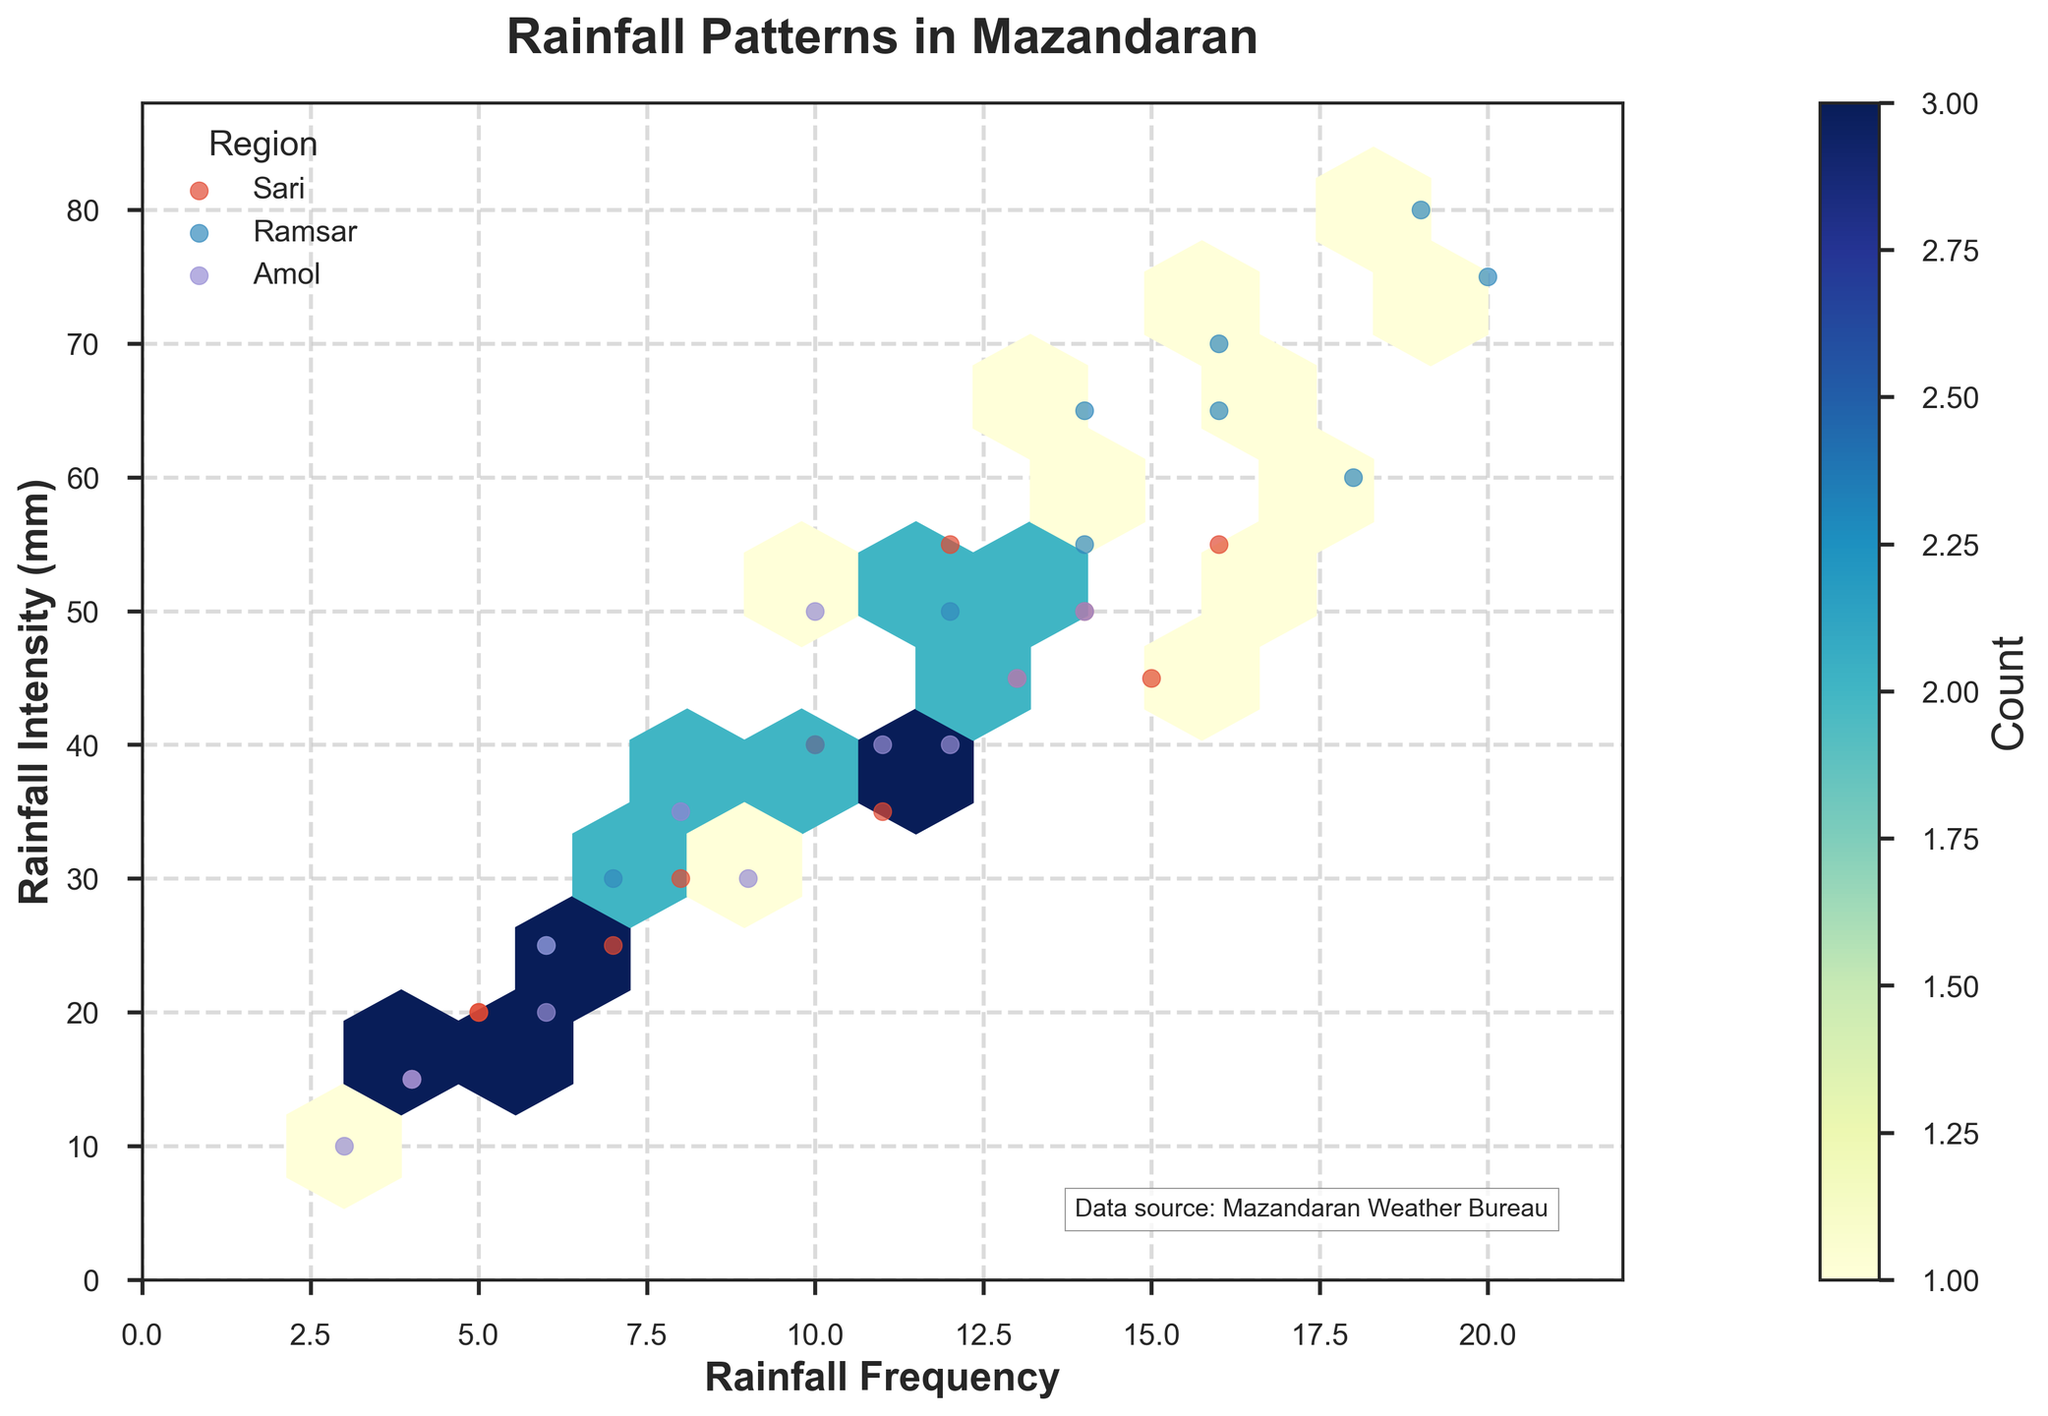What does the color represent in the hexbin plot? The color in the hexbin plot represents the count of data points (or observations) that fall into each hexagonal bin. Darker colors indicate higher counts.
Answer: Count of observations What is the title of the plot? The title is located at the top center of the plot and provides a brief description of the dataset being visualized. The title of this plot is "Rainfall Patterns in Mazandaran".
Answer: Rainfall Patterns in Mazandaran Which axis represents the rainfall intensity? The y-axis of the plot represents the rainfall intensity. It is labeled "Rainfall Intensity (mm)".
Answer: y-axis How is the color scale labeled in the hexbin plot? The color scale is labeled with the term "Count", which indicates the number of observations within each hexagonal bin.
Answer: Count Based on the plot, which region seems to have the highest rainfall frequency? By observing the scatter points, Ramsar generally has higher rainfall frequency values compared to Sari and Amol.
Answer: Ramsar Which region tends to have higher rainfall intensity when the frequency is around 10? When the rainfall frequency is around 10, Ramsar tends to have higher rainfall intensities compared to Sari or Amol, as indicated by the positioning of the scatter points.
Answer: Ramsar What is the range of rainfall frequency values shown in the plot? The rainfall frequency values on the x-axis range from around 0 to a little over 20.
Answer: 0 to 20+ If a month has a rainfall frequency of 5, what is the range of rainfall intensities observed? Observations for the frequency of 5 show that rainfall intensity lies roughly between 15 and 20 mm.
Answer: 15 to 20 mm How does the density of rainfall data points vary for higher intensities? The higher rainfall intensity points (above 60 mm) tend to be less dense and spaced out, indicating fewer observations.
Answer: Less dense What trends can you observe about the relationship between rainfall frequency and intensity? In general, higher rainfall frequency tends to be associated with higher rainfall intensity, as observed from the clustering of points moving upward along with the x-axis.
Answer: Positive correlation 